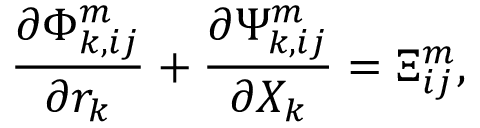Convert formula to latex. <formula><loc_0><loc_0><loc_500><loc_500>\frac { \partial \Phi _ { k , i j } ^ { m } } { \partial r _ { k } } + \frac { \partial \Psi _ { k , i j } ^ { m } } { \partial X _ { k } } = \Xi _ { i j } ^ { m } ,</formula> 